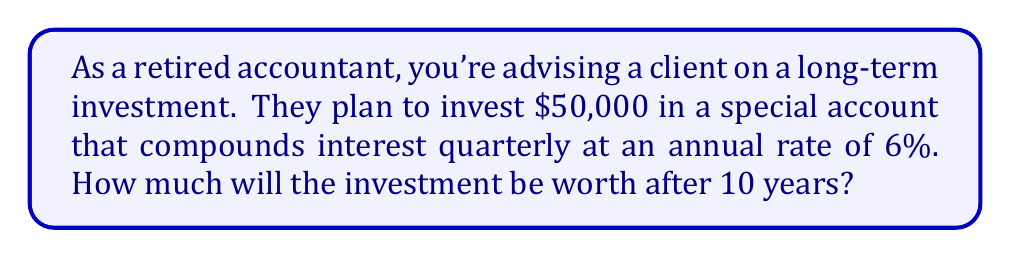Solve this math problem. Let's approach this step-by-step:

1) First, we need to identify the variables:
   Principal (P) = $50,000
   Annual interest rate (r) = 6% = 0.06
   Number of years (t) = 10
   Number of times interest is compounded per year (n) = 4 (quarterly)

2) We'll use the compound interest formula:
   $$A = P(1 + \frac{r}{n})^{nt}$$
   Where A is the final amount.

3) Let's substitute our values:
   $$A = 50000(1 + \frac{0.06}{4})^{4(10)}$$

4) Simplify inside the parentheses:
   $$A = 50000(1 + 0.015)^{40}$$

5) Calculate the power:
   $$A = 50000(1.015)^{40}$$

6) Use a calculator to compute this:
   $$A = 50000 * 1.816701765$$
   $$A = 90835.09$$

7) Rounding to the nearest cent:
   $$A = 90835.09$$

Therefore, after 10 years, the investment will be worth $90,835.09.
Answer: $90,835.09 